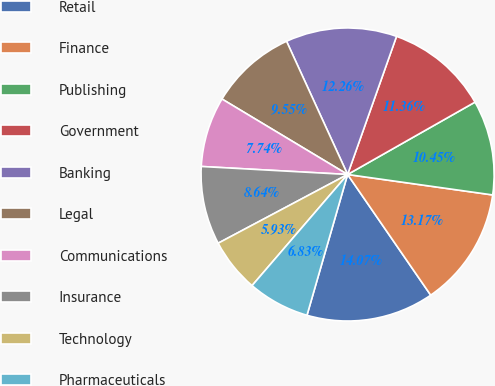Convert chart to OTSL. <chart><loc_0><loc_0><loc_500><loc_500><pie_chart><fcel>Retail<fcel>Finance<fcel>Publishing<fcel>Government<fcel>Banking<fcel>Legal<fcel>Communications<fcel>Insurance<fcel>Technology<fcel>Pharmaceuticals<nl><fcel>14.07%<fcel>13.17%<fcel>10.45%<fcel>11.36%<fcel>12.26%<fcel>9.55%<fcel>7.74%<fcel>8.64%<fcel>5.93%<fcel>6.83%<nl></chart> 